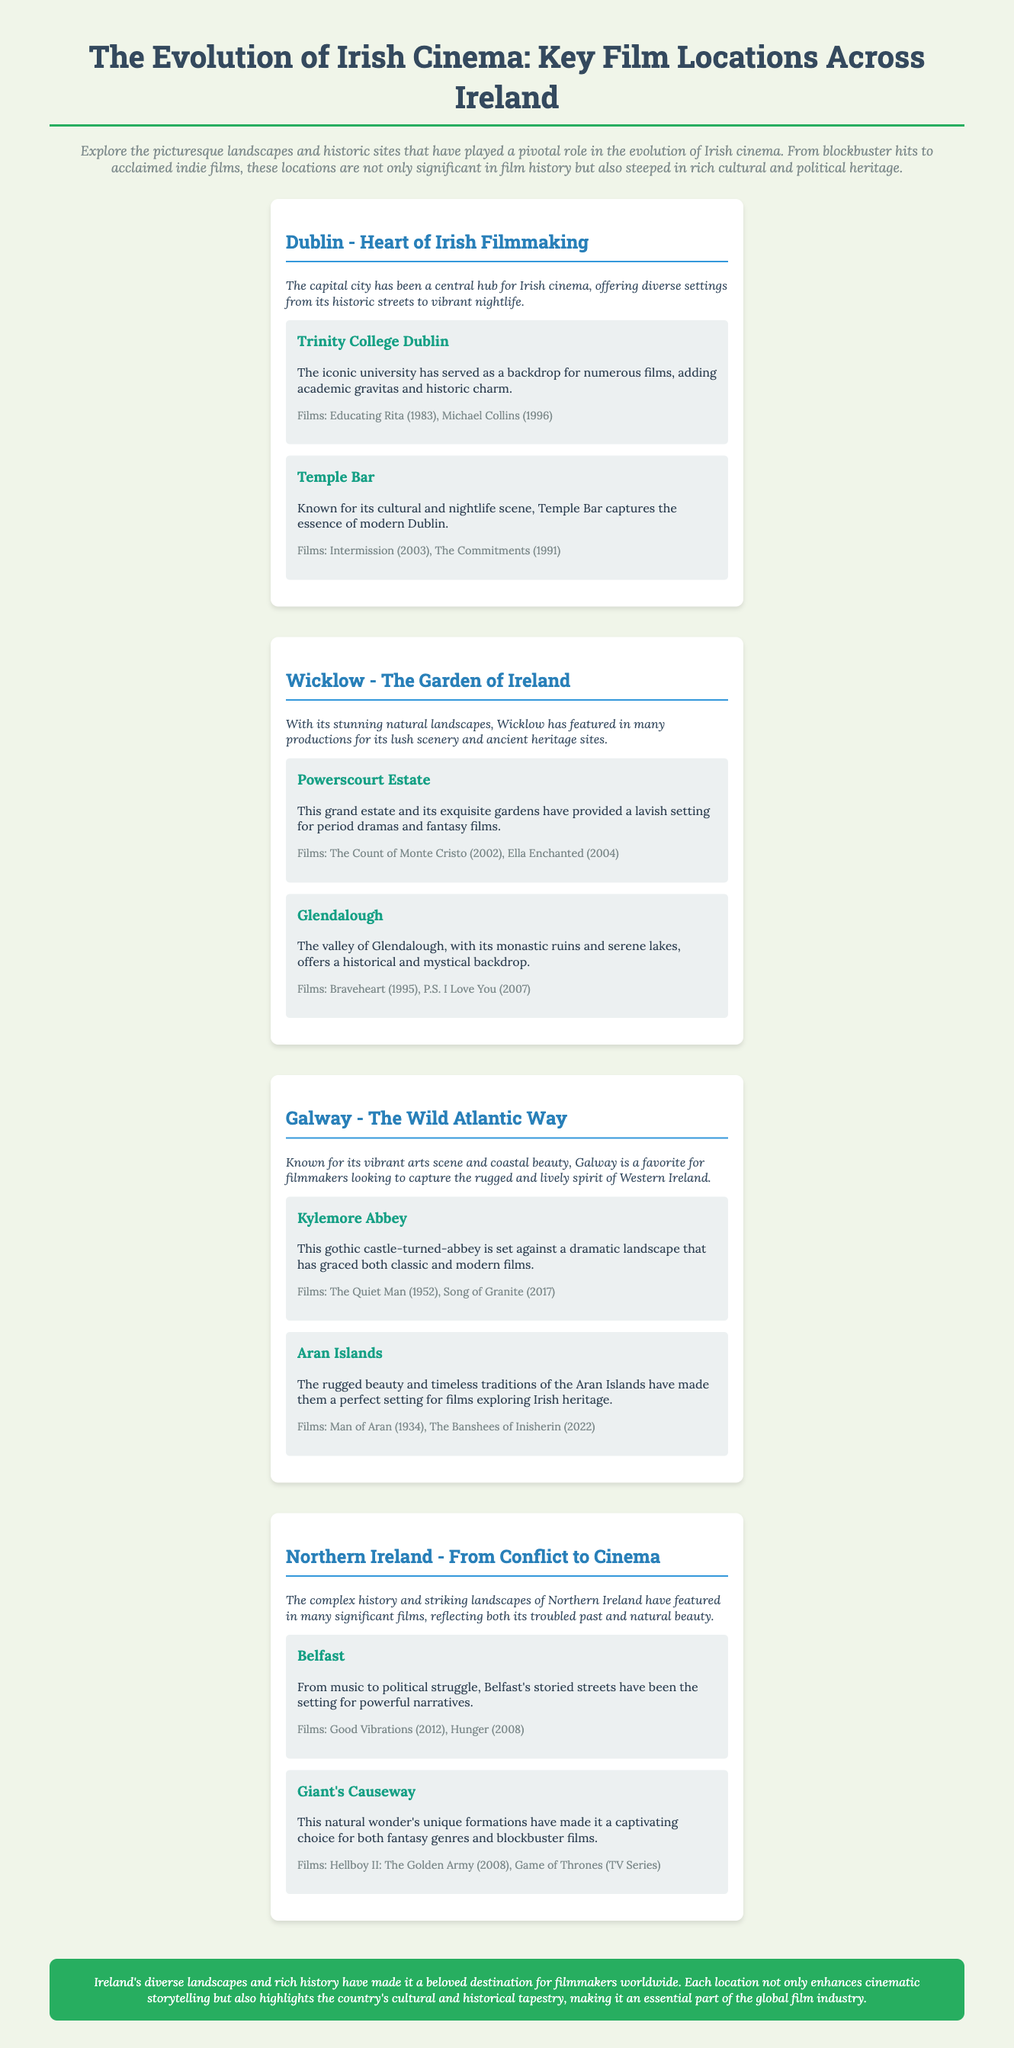What city is referred to as the "Heart of Irish Filmmaking"? The document highlights Dublin as the central hub for Irish cinema, indicating its importance in the film industry.
Answer: Dublin Which estate in Wicklow has provided a setting for period dramas? Powerscourt Estate is mentioned as a grand estate that has served as a backdrop for various films.
Answer: Powerscourt Estate What is the iconic university located in Dublin? Trinity College Dublin is identified in the document as a significant location for multiple films.
Answer: Trinity College Dublin Name one film shot at Kylemore Abbey. The document lists films associated with various locations, identifying "The Quiet Man" as shot at Kylemore Abbey.
Answer: The Quiet Man Which two locations in Galway are highlighted in the document? The document mentions Kylemore Abbey and the Aran Islands as significant film locations in Galway.
Answer: Kylemore Abbey, Aran Islands What is the primary focus of the infographic? The infographic centers on the key film locations across Ireland and their significance in the evolution of Irish cinema.
Answer: Key film locations across Ireland Name a film that features Temple Bar. The document provides examples of films associated with Temple Bar, specifically mentioning "The Commitments".
Answer: The Commitments What is the color of the conclusion section in the document? The conclusion section has a green background color, which is specified in the styling of the document.
Answer: Green 